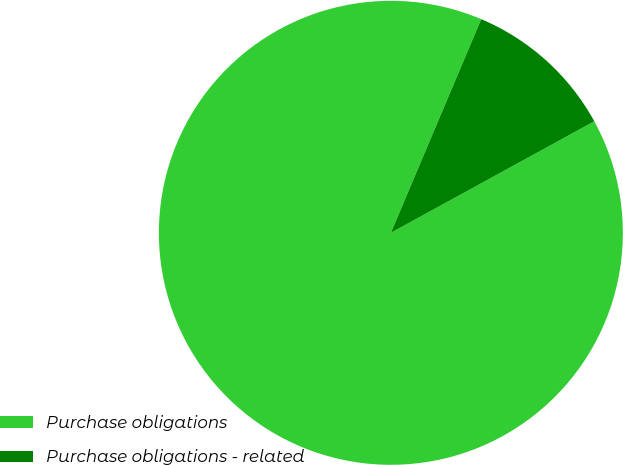Convert chart to OTSL. <chart><loc_0><loc_0><loc_500><loc_500><pie_chart><fcel>Purchase obligations<fcel>Purchase obligations - related<nl><fcel>89.35%<fcel>10.65%<nl></chart> 